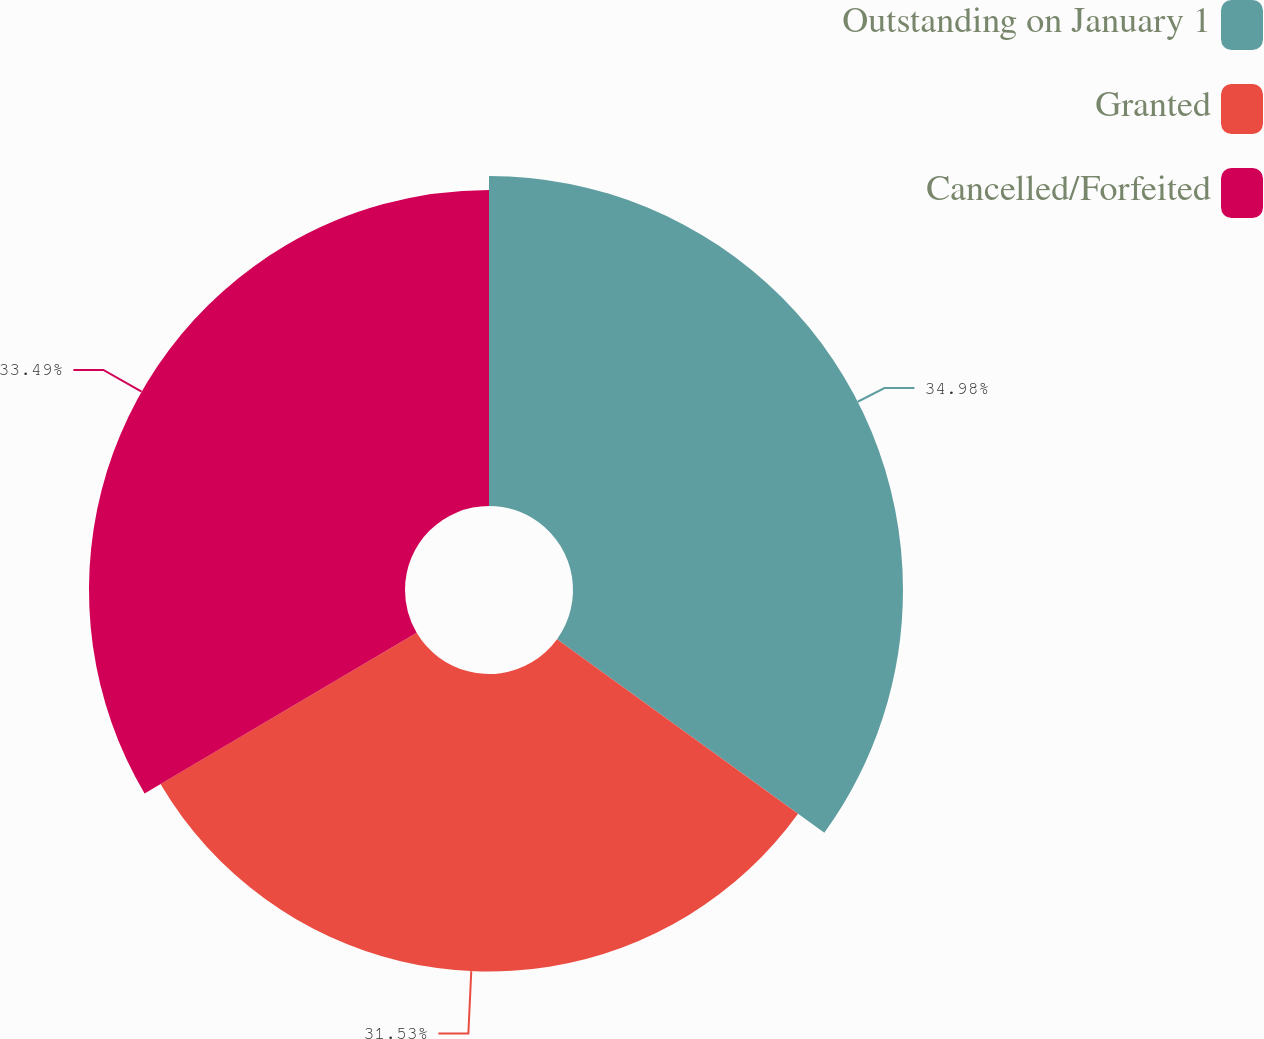Convert chart to OTSL. <chart><loc_0><loc_0><loc_500><loc_500><pie_chart><fcel>Outstanding on January 1<fcel>Granted<fcel>Cancelled/Forfeited<nl><fcel>34.97%<fcel>31.53%<fcel>33.49%<nl></chart> 